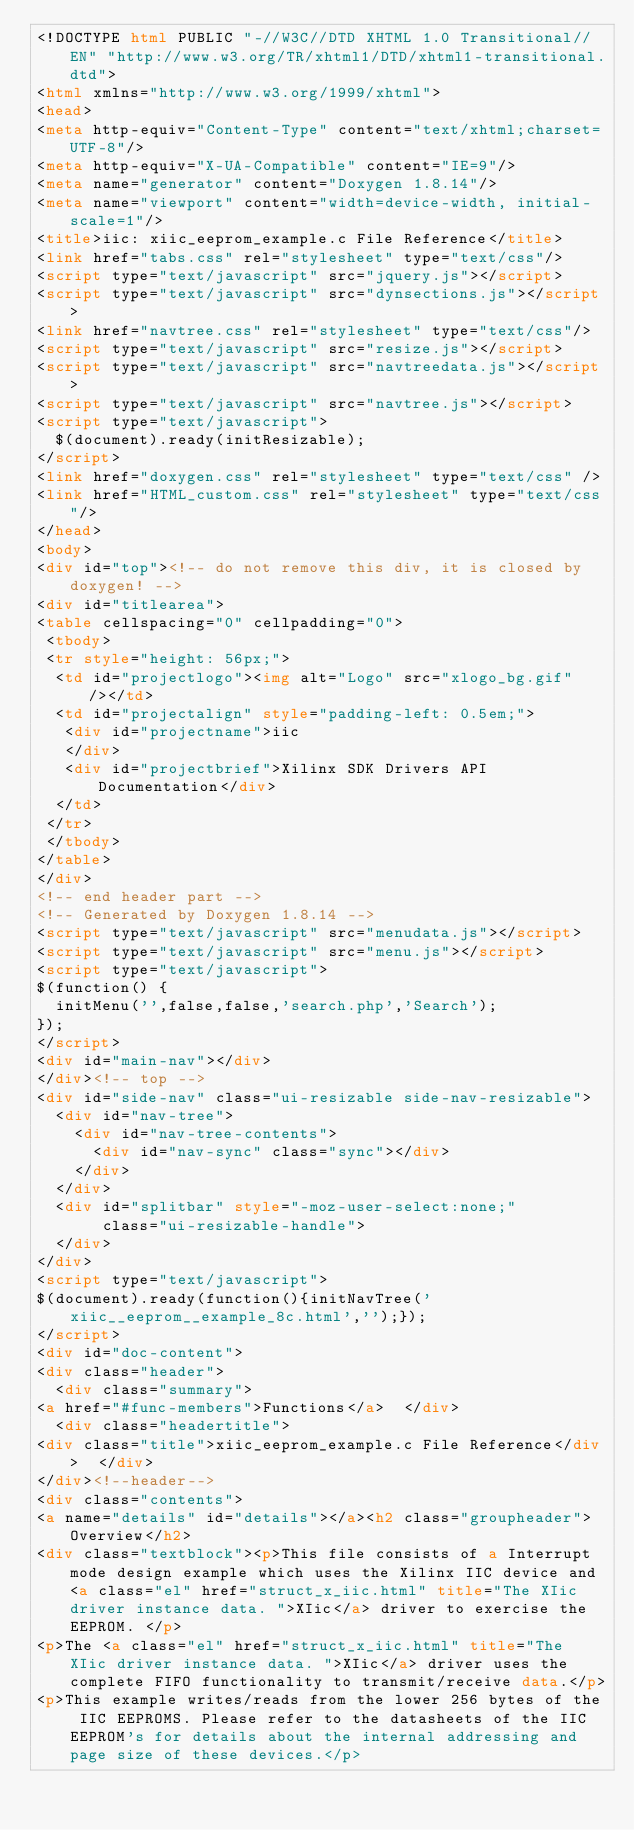<code> <loc_0><loc_0><loc_500><loc_500><_HTML_><!DOCTYPE html PUBLIC "-//W3C//DTD XHTML 1.0 Transitional//EN" "http://www.w3.org/TR/xhtml1/DTD/xhtml1-transitional.dtd">
<html xmlns="http://www.w3.org/1999/xhtml">
<head>
<meta http-equiv="Content-Type" content="text/xhtml;charset=UTF-8"/>
<meta http-equiv="X-UA-Compatible" content="IE=9"/>
<meta name="generator" content="Doxygen 1.8.14"/>
<meta name="viewport" content="width=device-width, initial-scale=1"/>
<title>iic: xiic_eeprom_example.c File Reference</title>
<link href="tabs.css" rel="stylesheet" type="text/css"/>
<script type="text/javascript" src="jquery.js"></script>
<script type="text/javascript" src="dynsections.js"></script>
<link href="navtree.css" rel="stylesheet" type="text/css"/>
<script type="text/javascript" src="resize.js"></script>
<script type="text/javascript" src="navtreedata.js"></script>
<script type="text/javascript" src="navtree.js"></script>
<script type="text/javascript">
  $(document).ready(initResizable);
</script>
<link href="doxygen.css" rel="stylesheet" type="text/css" />
<link href="HTML_custom.css" rel="stylesheet" type="text/css"/>
</head>
<body>
<div id="top"><!-- do not remove this div, it is closed by doxygen! -->
<div id="titlearea">
<table cellspacing="0" cellpadding="0">
 <tbody>
 <tr style="height: 56px;">
  <td id="projectlogo"><img alt="Logo" src="xlogo_bg.gif"/></td>
  <td id="projectalign" style="padding-left: 0.5em;">
   <div id="projectname">iic
   </div>
   <div id="projectbrief">Xilinx SDK Drivers API Documentation</div>
  </td>
 </tr>
 </tbody>
</table>
</div>
<!-- end header part -->
<!-- Generated by Doxygen 1.8.14 -->
<script type="text/javascript" src="menudata.js"></script>
<script type="text/javascript" src="menu.js"></script>
<script type="text/javascript">
$(function() {
  initMenu('',false,false,'search.php','Search');
});
</script>
<div id="main-nav"></div>
</div><!-- top -->
<div id="side-nav" class="ui-resizable side-nav-resizable">
  <div id="nav-tree">
    <div id="nav-tree-contents">
      <div id="nav-sync" class="sync"></div>
    </div>
  </div>
  <div id="splitbar" style="-moz-user-select:none;" 
       class="ui-resizable-handle">
  </div>
</div>
<script type="text/javascript">
$(document).ready(function(){initNavTree('xiic__eeprom__example_8c.html','');});
</script>
<div id="doc-content">
<div class="header">
  <div class="summary">
<a href="#func-members">Functions</a>  </div>
  <div class="headertitle">
<div class="title">xiic_eeprom_example.c File Reference</div>  </div>
</div><!--header-->
<div class="contents">
<a name="details" id="details"></a><h2 class="groupheader">Overview</h2>
<div class="textblock"><p>This file consists of a Interrupt mode design example which uses the Xilinx IIC device and <a class="el" href="struct_x_iic.html" title="The XIic driver instance data. ">XIic</a> driver to exercise the EEPROM. </p>
<p>The <a class="el" href="struct_x_iic.html" title="The XIic driver instance data. ">XIic</a> driver uses the complete FIFO functionality to transmit/receive data.</p>
<p>This example writes/reads from the lower 256 bytes of the IIC EEPROMS. Please refer to the datasheets of the IIC EEPROM's for details about the internal addressing and page size of these devices.</p></code> 